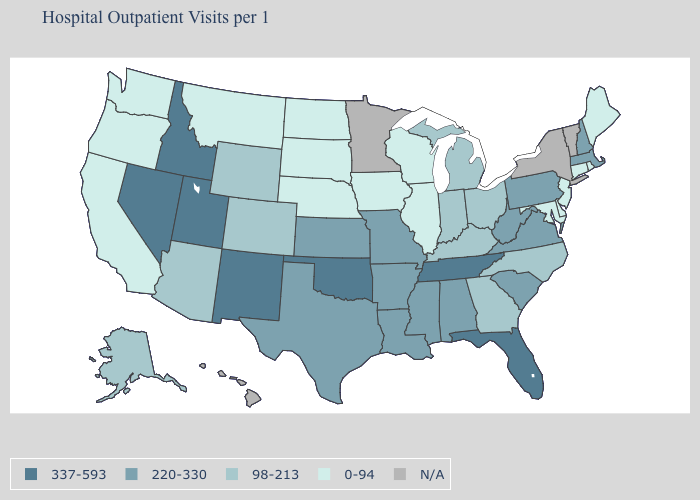Which states have the highest value in the USA?
Short answer required. Florida, Idaho, Nevada, New Mexico, Oklahoma, Tennessee, Utah. What is the lowest value in the Northeast?
Keep it brief. 0-94. Name the states that have a value in the range 98-213?
Keep it brief. Alaska, Arizona, Colorado, Georgia, Indiana, Kentucky, Michigan, North Carolina, Ohio, Wyoming. What is the value of New Mexico?
Give a very brief answer. 337-593. Does the map have missing data?
Be succinct. Yes. What is the value of Tennessee?
Write a very short answer. 337-593. What is the value of New York?
Short answer required. N/A. Name the states that have a value in the range 220-330?
Keep it brief. Alabama, Arkansas, Kansas, Louisiana, Massachusetts, Mississippi, Missouri, New Hampshire, Pennsylvania, South Carolina, Texas, Virginia, West Virginia. What is the lowest value in the South?
Concise answer only. 0-94. Name the states that have a value in the range N/A?
Concise answer only. Hawaii, Minnesota, New York, Vermont. Does the map have missing data?
Give a very brief answer. Yes. Which states have the lowest value in the MidWest?
Quick response, please. Illinois, Iowa, Nebraska, North Dakota, South Dakota, Wisconsin. What is the value of South Carolina?
Quick response, please. 220-330. Which states have the lowest value in the Northeast?
Be succinct. Connecticut, Maine, New Jersey, Rhode Island. 